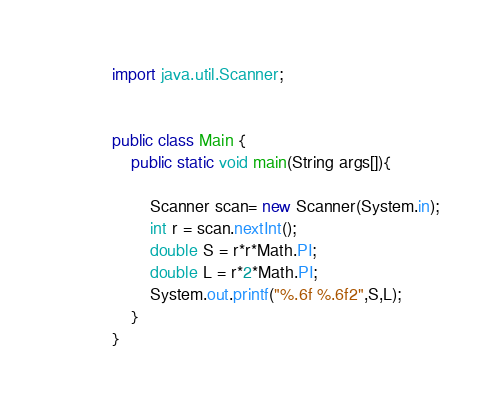<code> <loc_0><loc_0><loc_500><loc_500><_Java_>import java.util.Scanner;


public class Main {
	public static void main(String args[]){

		Scanner scan= new Scanner(System.in);
		int r = scan.nextInt();
		double S = r*r*Math.PI;
		double L = r*2*Math.PI;
		System.out.printf("%.6f %.6f2",S,L);
	}
}</code> 